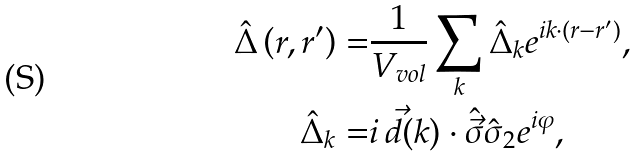Convert formula to latex. <formula><loc_0><loc_0><loc_500><loc_500>\hat { \Delta } \left ( r , r ^ { \prime } \right ) = & \frac { 1 } { V _ { v o l } } \sum _ { k } \hat { \Delta } _ { k } e ^ { i k \cdot ( r - r ^ { \prime } ) } , \\ \hat { \Delta } _ { k } = & i \, \vec { d } ( k ) \cdot \hat { \vec { \sigma } } \hat { \sigma } _ { 2 } e ^ { i \varphi } ,</formula> 